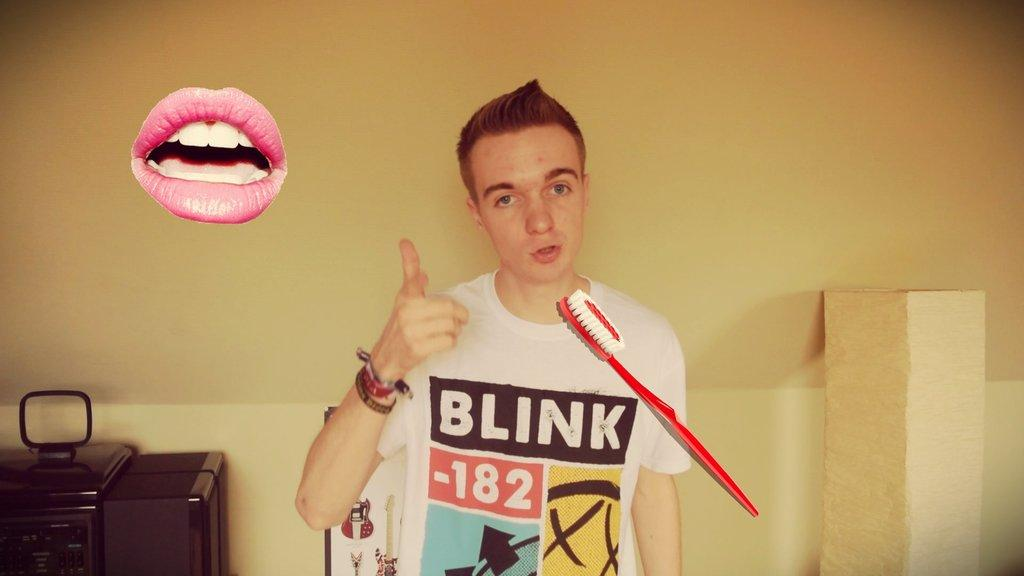Provide a one-sentence caption for the provided image. A teenage boy sports a Blink 182 t-shirt and a casual expression. 